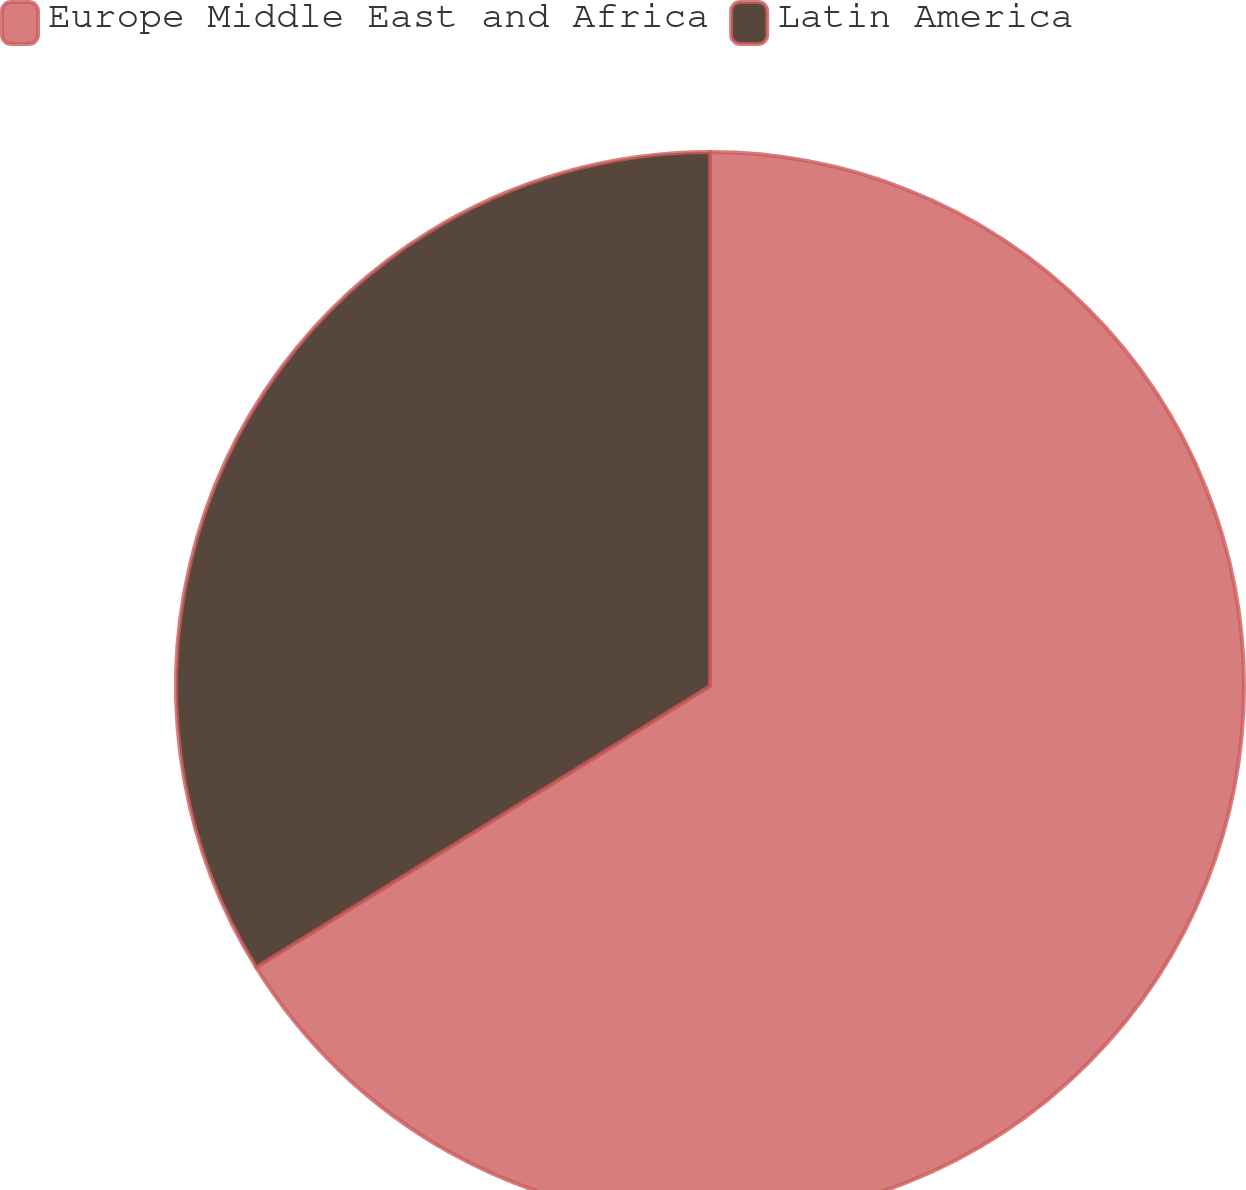Convert chart. <chart><loc_0><loc_0><loc_500><loc_500><pie_chart><fcel>Europe Middle East and Africa<fcel>Latin America<nl><fcel>66.17%<fcel>33.83%<nl></chart> 